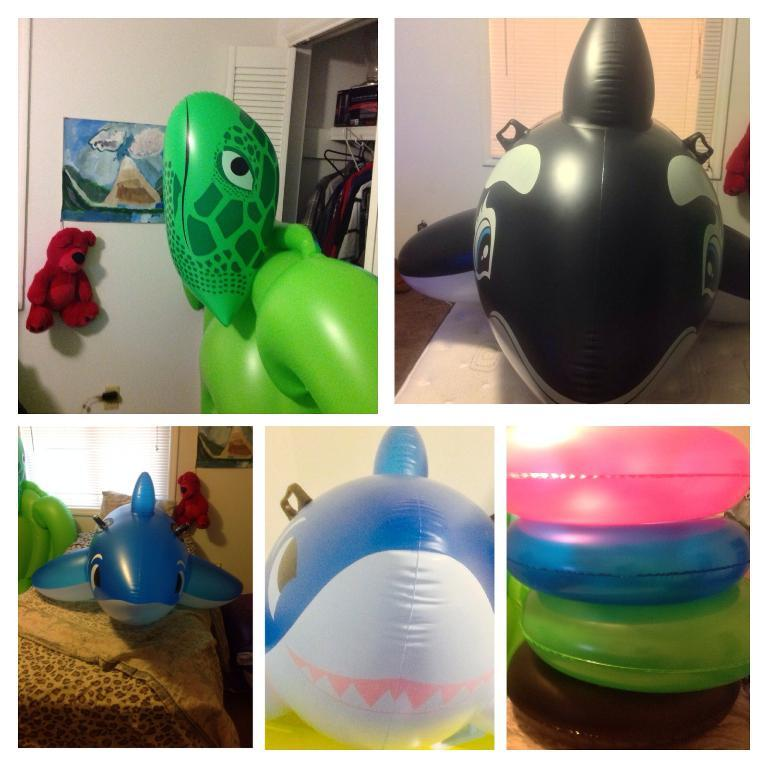What type of images are combined in the collage? The collage is made up of five images. What is the common theme among the images in the collage? Each image contains inflatables. Can you describe the appearance of the inflatables in the collage? The inflatables are of different colors. What type of noise can be heard coming from the inflatables in the image? There is no sound present in the image, so it is not possible to determine what noise might be heard. 